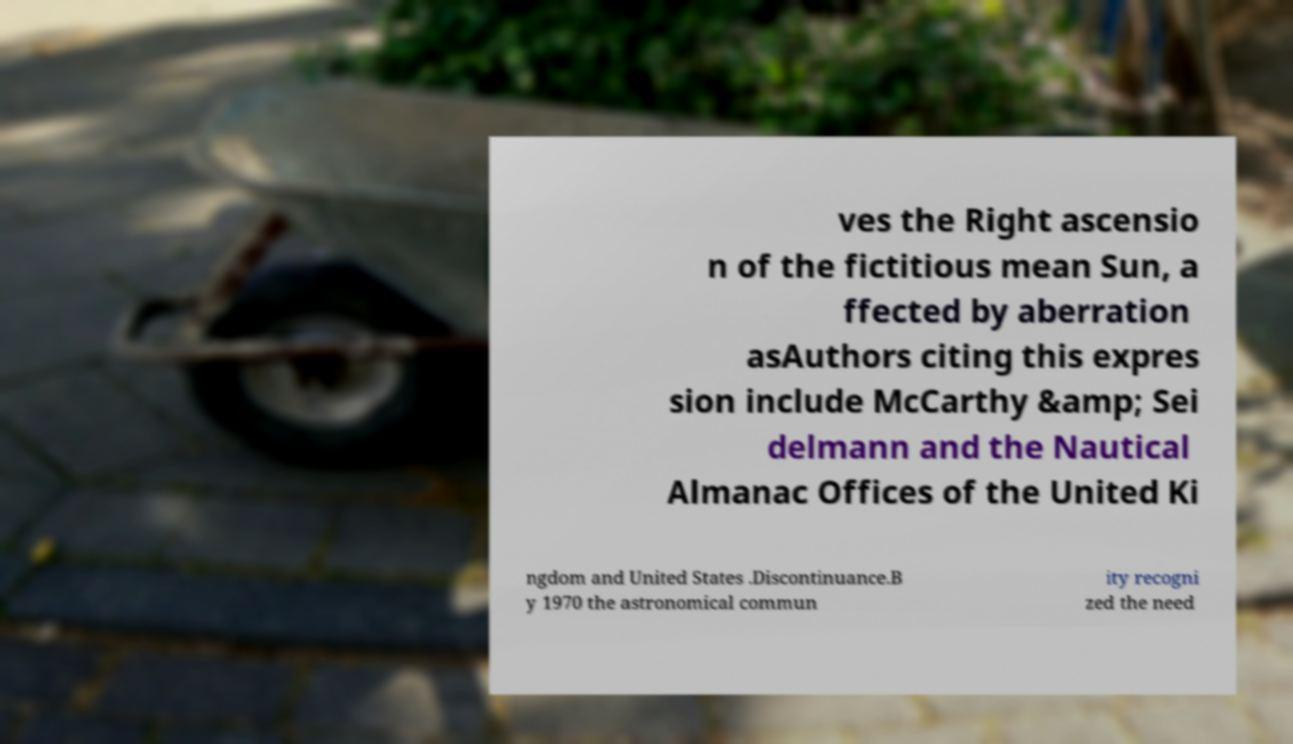Please identify and transcribe the text found in this image. ves the Right ascensio n of the fictitious mean Sun, a ffected by aberration asAuthors citing this expres sion include McCarthy &amp; Sei delmann and the Nautical Almanac Offices of the United Ki ngdom and United States .Discontinuance.B y 1970 the astronomical commun ity recogni zed the need 